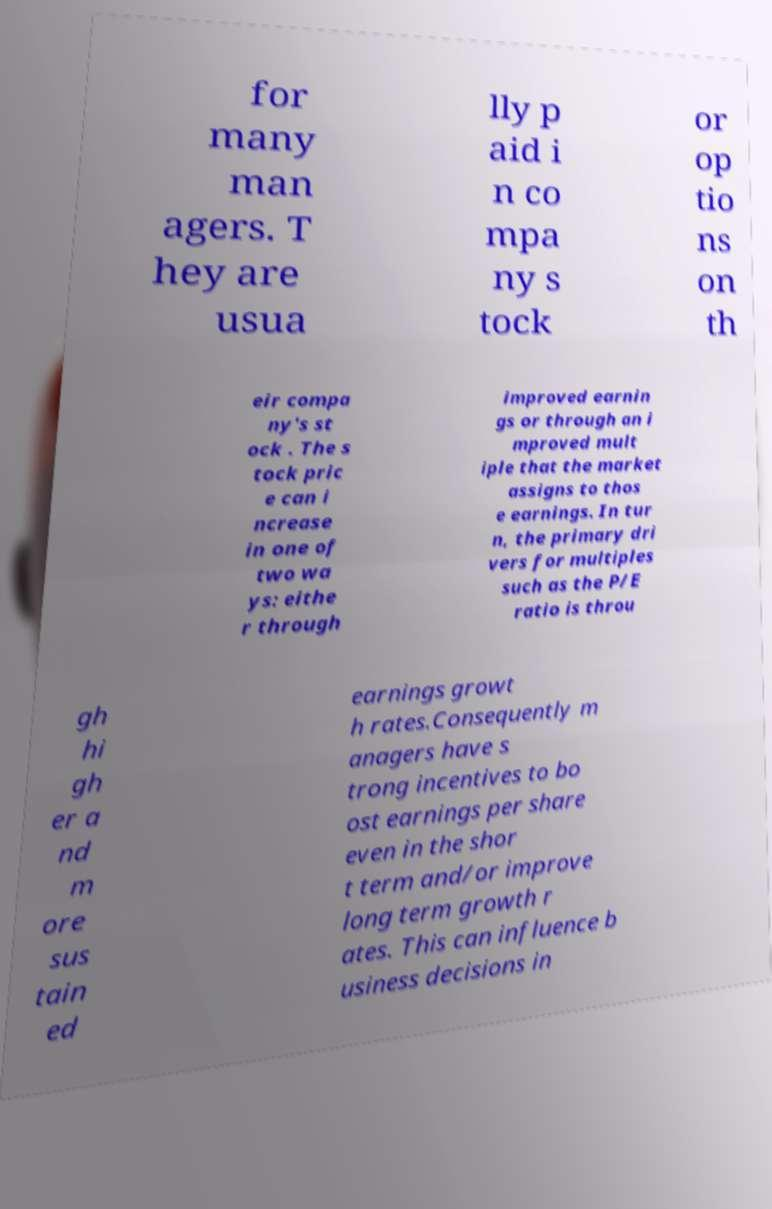For documentation purposes, I need the text within this image transcribed. Could you provide that? for many man agers. T hey are usua lly p aid i n co mpa ny s tock or op tio ns on th eir compa ny's st ock . The s tock pric e can i ncrease in one of two wa ys: eithe r through improved earnin gs or through an i mproved mult iple that the market assigns to thos e earnings. In tur n, the primary dri vers for multiples such as the P/E ratio is throu gh hi gh er a nd m ore sus tain ed earnings growt h rates.Consequently m anagers have s trong incentives to bo ost earnings per share even in the shor t term and/or improve long term growth r ates. This can influence b usiness decisions in 